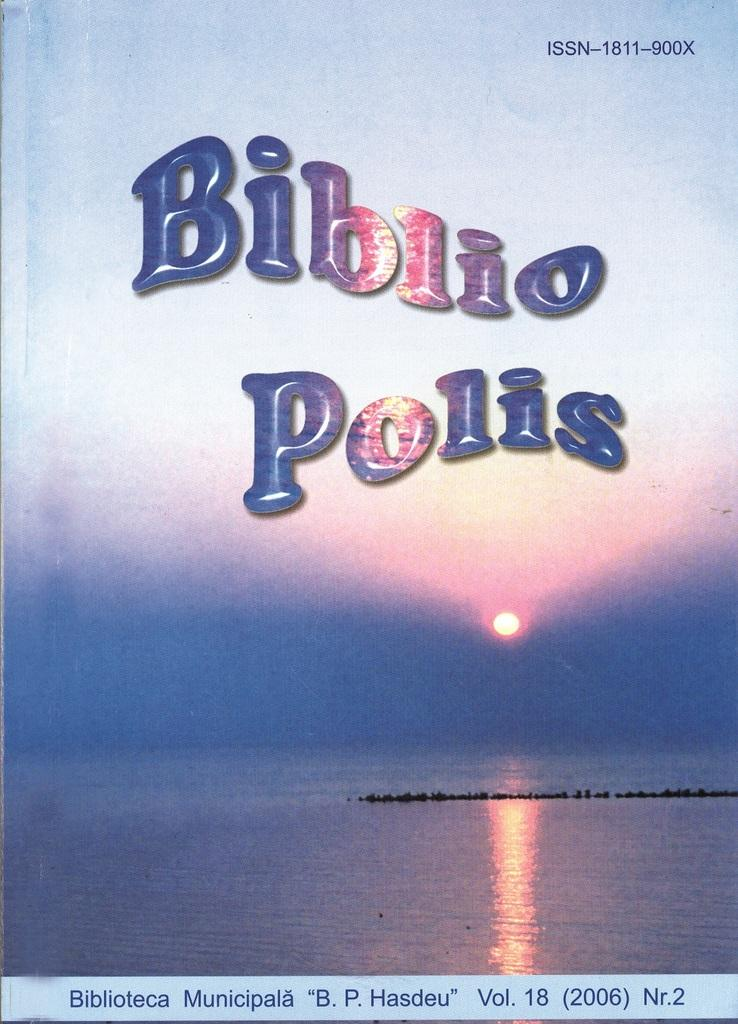<image>
Share a concise interpretation of the image provided. the word biblio that is on a sign 